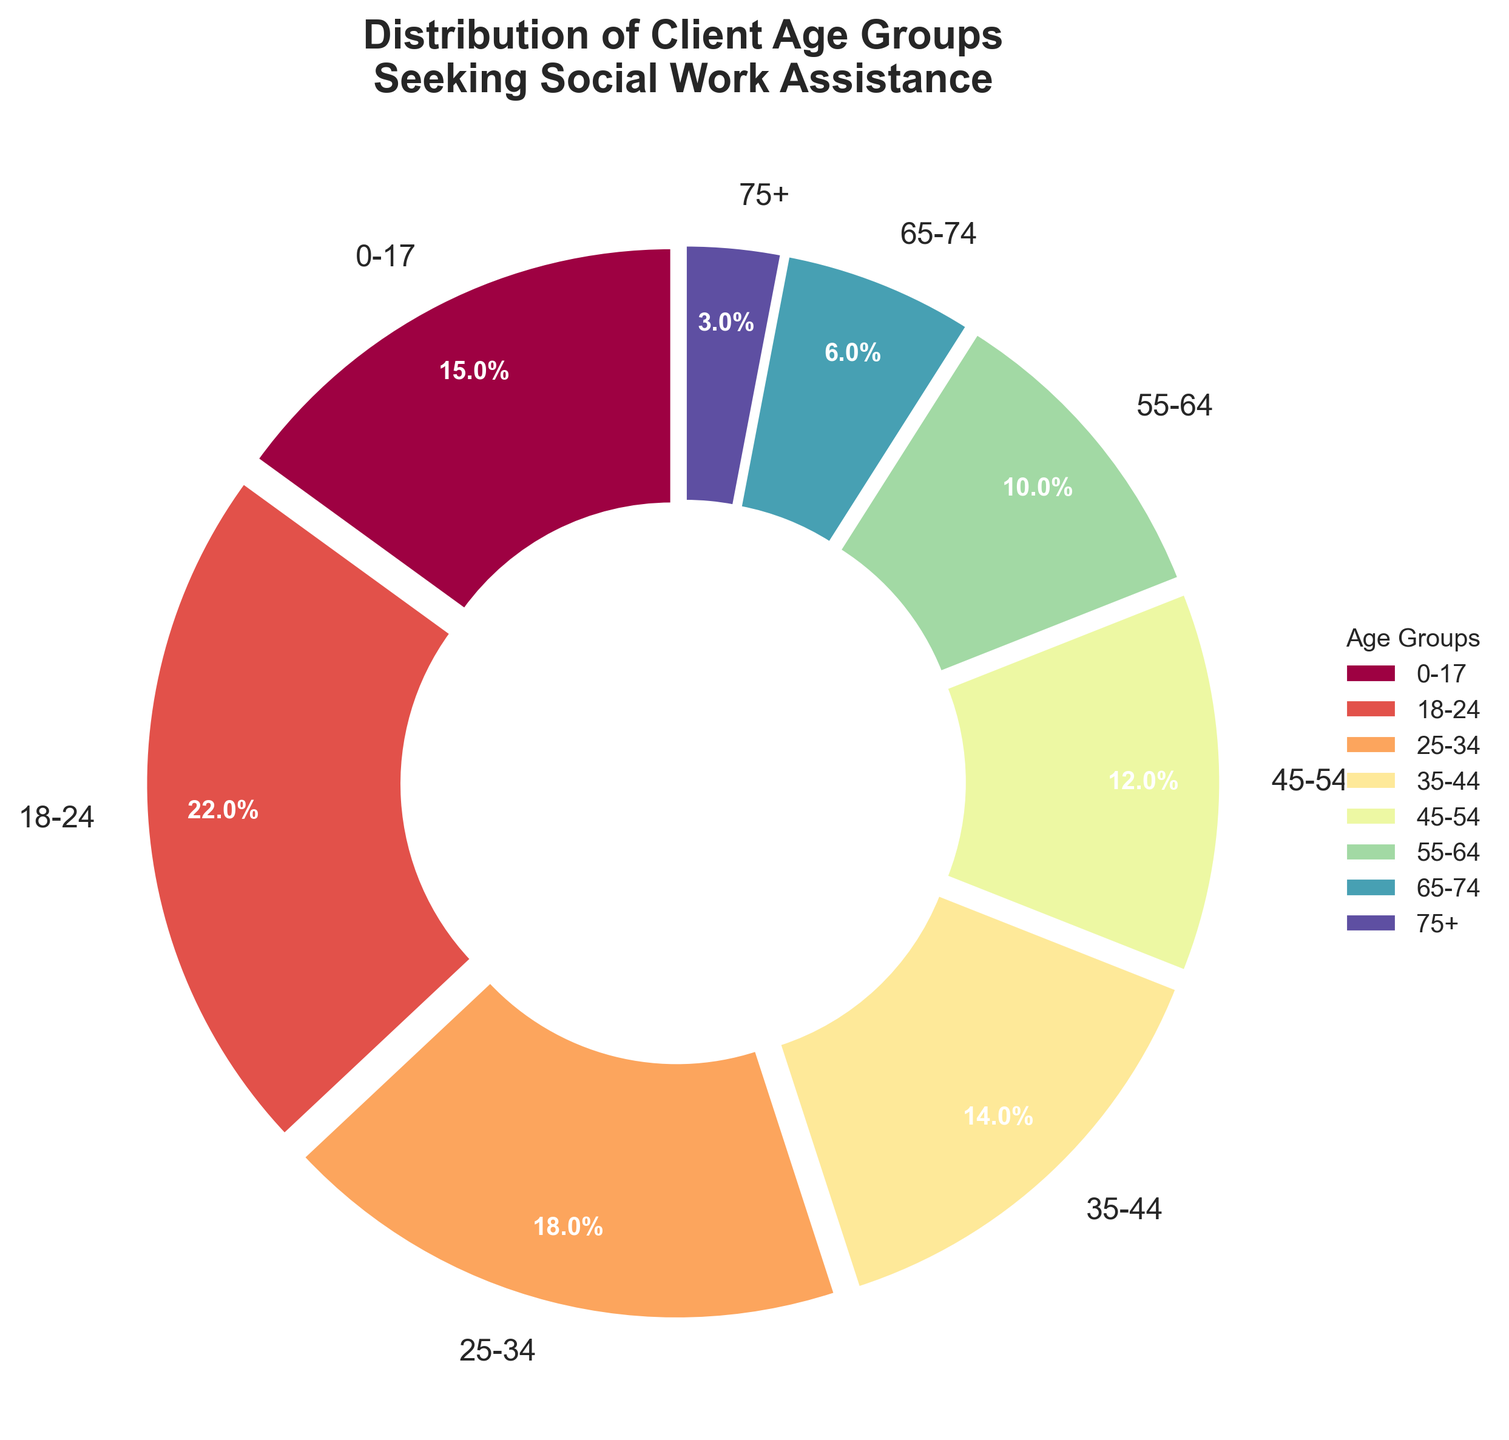What percentage of clients seeking social work assistance are under the age of 25? To find the percentage of clients under 25, add the percentages of the 0-17 age group and the 18-24 age group. The sum is 15% + 22% = 37%
Answer: 37% Which age group has the highest percentage of clients seeking assistance? Review the pie chart segments and detect the largest segment. The 18-24 age group has the largest slice at 22%.
Answer: 18-24 What is the difference in the percentage of clients between the 35-44 age group and the 55-64 age group? Subtract the percentage of the 55-64 age group from the percentage of the 35-44 age group. 14% - 10% = 4%
Answer: 4% How does the percentage of clients aged 45-54 compare to those aged 25-34? Compare the given percentages from the chart: 45-54 is 12% and 25-34 is 18%. 18% is higher than 12%.
Answer: 25-34 is higher What proportion of clients are aged 55 and above? Add the percentages for the 55-64, 65-74, and 75+ age groups. The sum is 10% + 6% + 3% = 19%.
Answer: 19% What color represents the 0-17 age group on the chart? Consult the color-coding of the pie chart segments. The 0-17 age group is identified by the segment closest to the start point of the pie.
Answer: The specific color from the palette used How does the client distribution of the 65+ age group compare to the 18-24 age group? Add percentages of the 65-74 and 75+ age groups and compare to the 18-24 group. 6% + 3% = 9% which is less than 22%.
Answer: 18-24 is higher What is the combined percentage of clients aged 25-44? Sum the percentages of the 25-34 and 35-44 age groups. 18% + 14% = 32%
Answer: 32% Which age group has the smallest percentage of clients? Identify the smallest slice of the pie chart. The 75+ age group has the smallest percentage at 3%.
Answer: 75+ What would be the new pie chart percentage for the 0-34 age group if merged? Add the percentages of the 0-17, 18-24, and 25-34 age groups. 15% + 22% + 18% = 55%.
Answer: 55% 